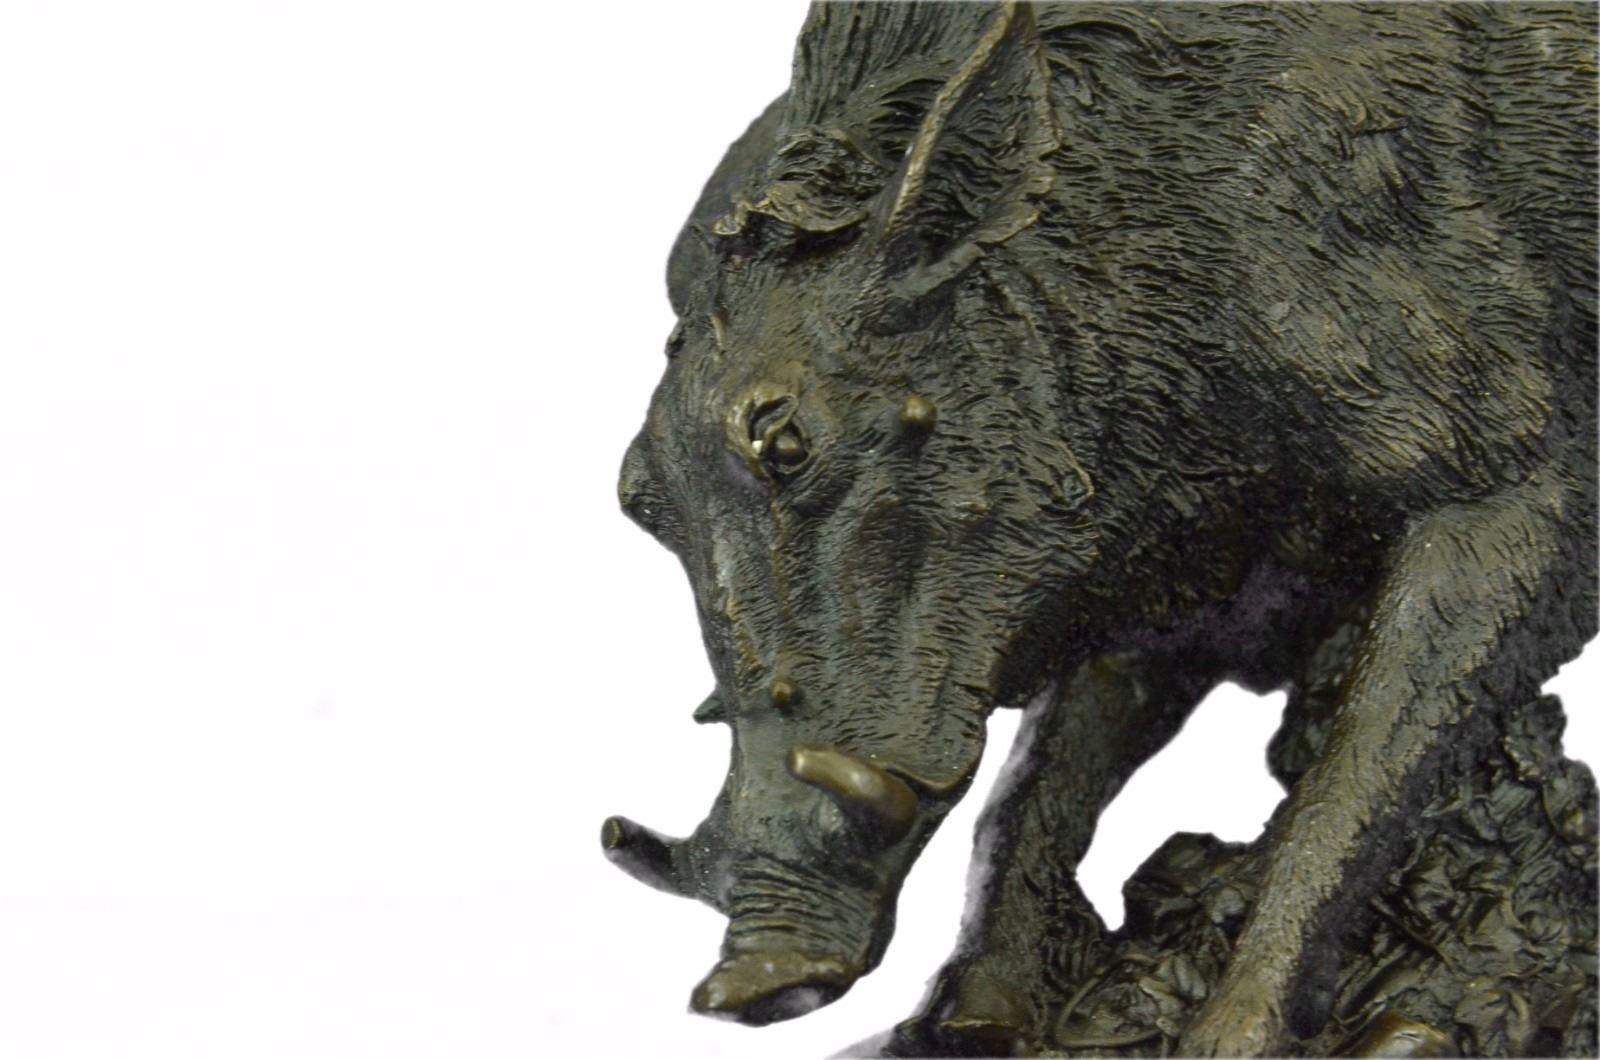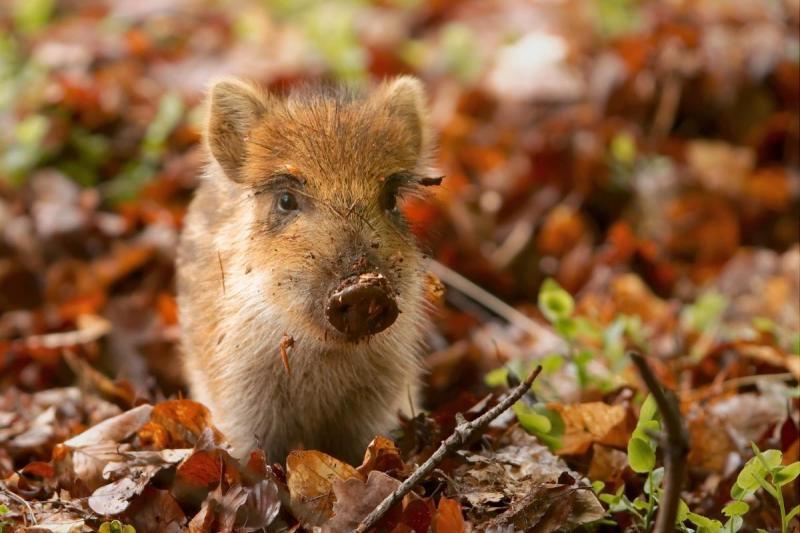The first image is the image on the left, the second image is the image on the right. For the images displayed, is the sentence "One image shows an actual wild pig bounding across the ground in profile, and each image includes an animal figure in a motion pose." factually correct? Answer yes or no. No. The first image is the image on the left, the second image is the image on the right. Evaluate the accuracy of this statement regarding the images: "At least one wild boar is running toward the right, and another wild boar is running toward the left.". Is it true? Answer yes or no. No. 